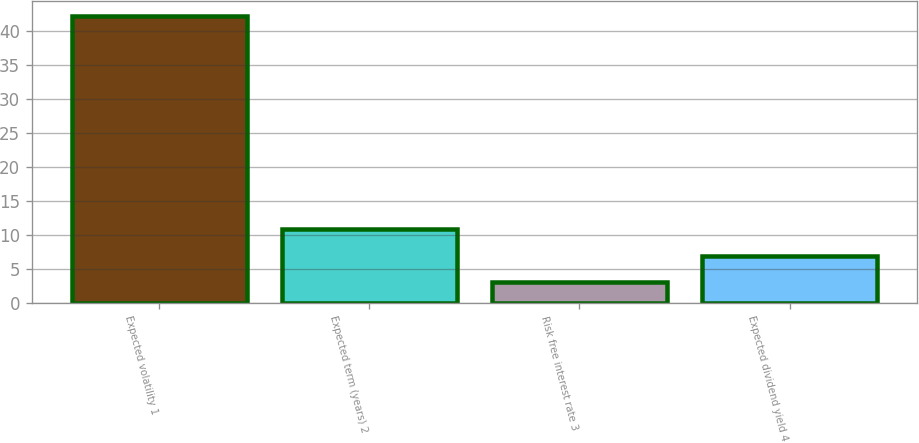<chart> <loc_0><loc_0><loc_500><loc_500><bar_chart><fcel>Expected volatility 1<fcel>Expected term (years) 2<fcel>Risk free interest rate 3<fcel>Expected dividend yield 4<nl><fcel>42.2<fcel>10.84<fcel>3<fcel>6.92<nl></chart> 